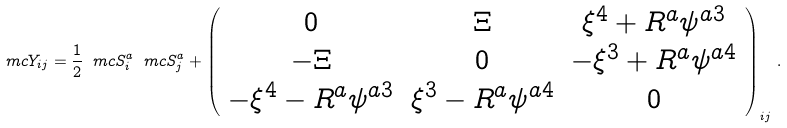<formula> <loc_0><loc_0><loc_500><loc_500>\ m c { Y } _ { i j } = \frac { 1 } { 2 } \ m c { S } ^ { a } _ { i } \ m c { S } ^ { a } _ { j } + \left ( \begin{array} { c c c } 0 & { \Xi } & { \xi } ^ { 4 } + { R } ^ { a } { \psi } ^ { a 3 } \\ - { \Xi } & 0 & - { \xi } ^ { 3 } + { R } ^ { a } { \psi } ^ { a 4 } \\ - { \xi } ^ { 4 } - { R } ^ { a } { \psi } ^ { a 3 } & { \xi } ^ { 3 } - { R } ^ { a } { \psi } ^ { a 4 } & 0 \end{array} \right ) _ { i j } \, .</formula> 